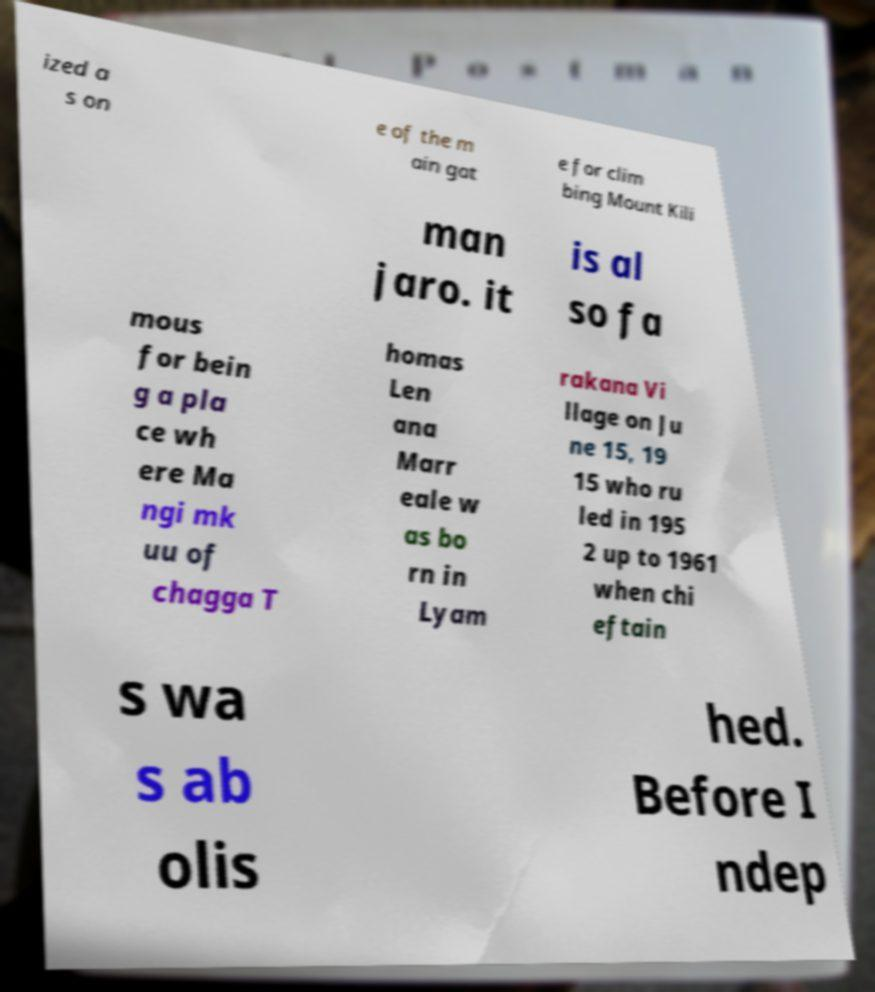Could you assist in decoding the text presented in this image and type it out clearly? ized a s on e of the m ain gat e for clim bing Mount Kili man jaro. it is al so fa mous for bein g a pla ce wh ere Ma ngi mk uu of chagga T homas Len ana Marr eale w as bo rn in Lyam rakana Vi llage on Ju ne 15, 19 15 who ru led in 195 2 up to 1961 when chi eftain s wa s ab olis hed. Before I ndep 